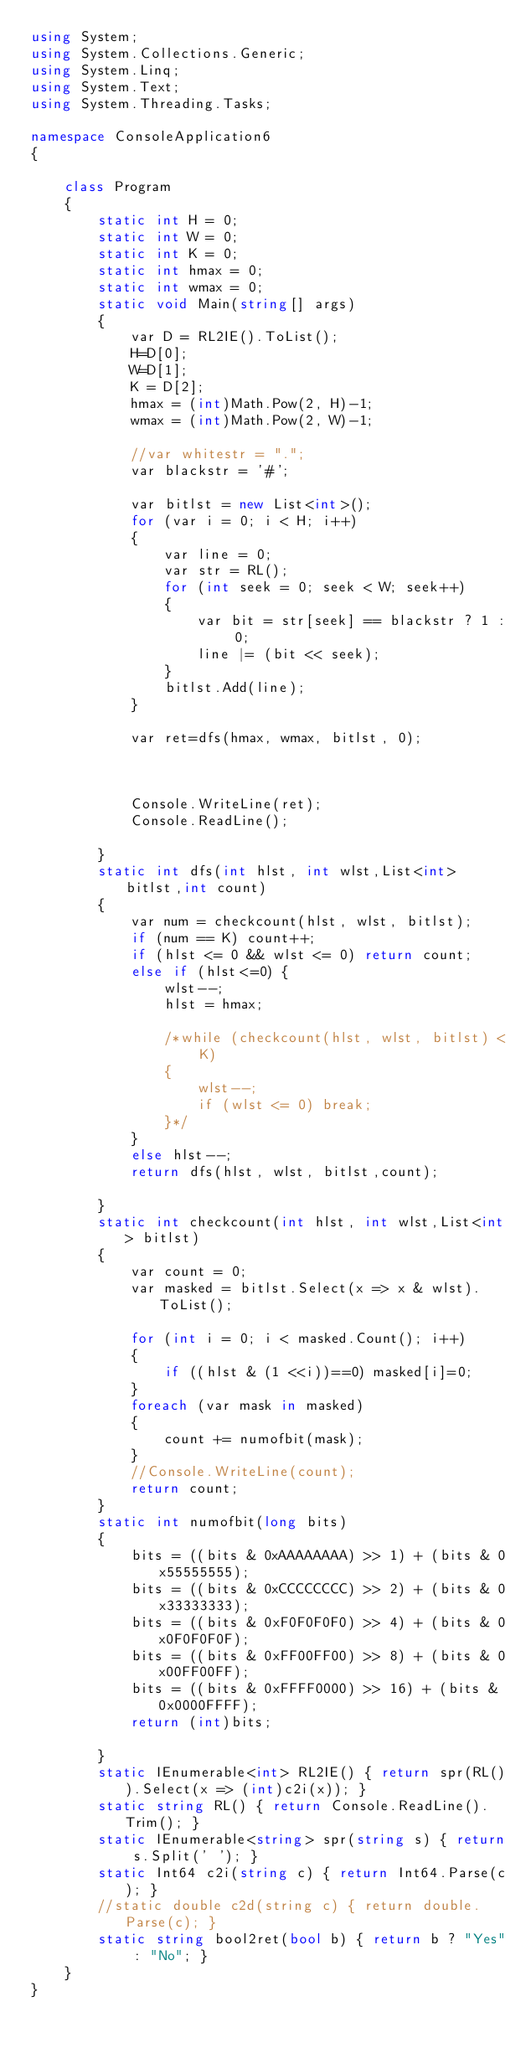<code> <loc_0><loc_0><loc_500><loc_500><_C#_>using System;
using System.Collections.Generic;
using System.Linq;
using System.Text;
using System.Threading.Tasks;

namespace ConsoleApplication6
{

    class Program
    {
        static int H = 0;
        static int W = 0;
        static int K = 0;
        static int hmax = 0;
        static int wmax = 0;
        static void Main(string[] args)
        {
            var D = RL2IE().ToList();
            H=D[0];
            W=D[1];
            K = D[2];
            hmax = (int)Math.Pow(2, H)-1;
            wmax = (int)Math.Pow(2, W)-1;

            //var whitestr = ".";
            var blackstr = '#';

            var bitlst = new List<int>();
            for (var i = 0; i < H; i++)
            {
                var line = 0;
                var str = RL();
                for (int seek = 0; seek < W; seek++)
                {
                    var bit = str[seek] == blackstr ? 1 : 0;
                    line |= (bit << seek);
                }
                bitlst.Add(line);
            }

            var ret=dfs(hmax, wmax, bitlst, 0);



            Console.WriteLine(ret);
            Console.ReadLine();

        }
        static int dfs(int hlst, int wlst,List<int> bitlst,int count)
        {
            var num = checkcount(hlst, wlst, bitlst);
            if (num == K) count++;
            if (hlst <= 0 && wlst <= 0) return count;
            else if (hlst<=0) {
                wlst--; 
                hlst = hmax;

                /*while (checkcount(hlst, wlst, bitlst) < K)
                {
                    wlst--;
                    if (wlst <= 0) break;
                }*/
            }
            else hlst--;
            return dfs(hlst, wlst, bitlst,count);
           
        }
        static int checkcount(int hlst, int wlst,List<int> bitlst)
        {
            var count = 0;
            var masked = bitlst.Select(x => x & wlst).ToList();

            for (int i = 0; i < masked.Count(); i++)
            {
                if ((hlst & (1 <<i))==0) masked[i]=0;
            }
            foreach (var mask in masked)
            {
                count += numofbit(mask);
            }
            //Console.WriteLine(count);
            return count;
        }
        static int numofbit(long bits)
        {
            bits = ((bits & 0xAAAAAAAA) >> 1) + (bits & 0x55555555);
            bits = ((bits & 0xCCCCCCCC) >> 2) + (bits & 0x33333333);
            bits = ((bits & 0xF0F0F0F0) >> 4) + (bits & 0x0F0F0F0F);
            bits = ((bits & 0xFF00FF00) >> 8) + (bits & 0x00FF00FF);
            bits = ((bits & 0xFFFF0000) >> 16) + (bits & 0x0000FFFF);
            return (int)bits;

        }
        static IEnumerable<int> RL2IE() { return spr(RL()).Select(x => (int)c2i(x)); }
        static string RL() { return Console.ReadLine().Trim(); }
        static IEnumerable<string> spr(string s) { return s.Split(' '); }
        static Int64 c2i(string c) { return Int64.Parse(c); }
        //static double c2d(string c) { return double.Parse(c); }
        static string bool2ret(bool b) { return b ? "Yes" : "No"; }
    }
}
</code> 